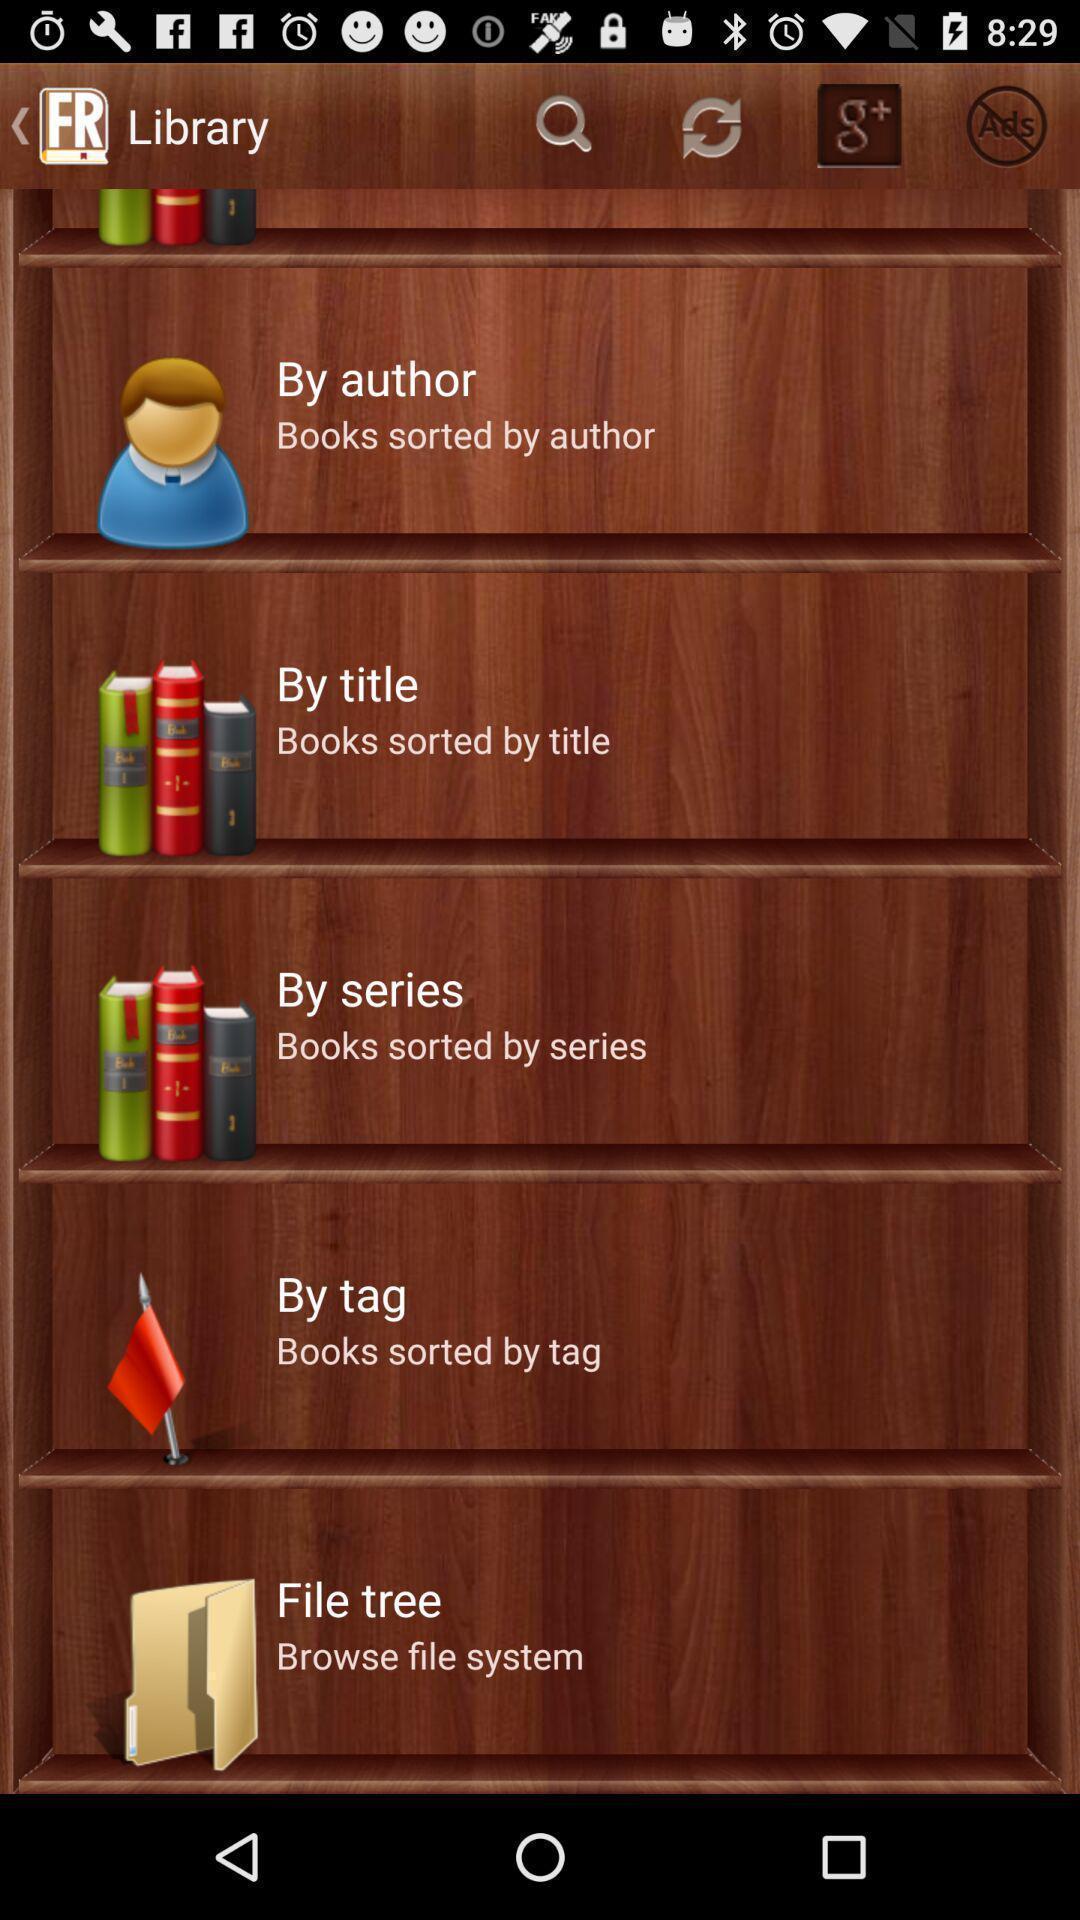Summarize the information in this screenshot. Screen shows multiple options in a reading application. 